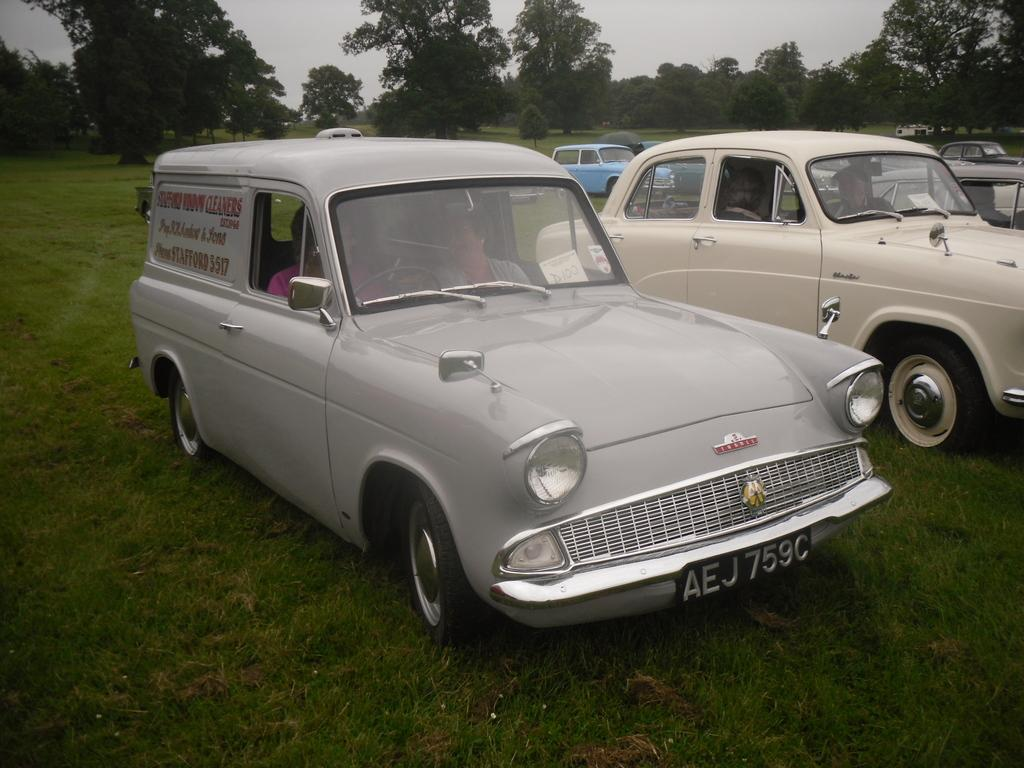What is the primary vegetation covering the land in the image? The land is covered with grass. What can be seen in addition to the grass? There are vehicles in the image. What are the people in the vehicles doing? People are sitting inside the vehicles. What can be seen in the distance in the image? There are trees in the background of the image. What type of art can be seen hanging from the trees in the image? There is no art visible in the image, as it features grass-covered land, vehicles, and people sitting inside them. 